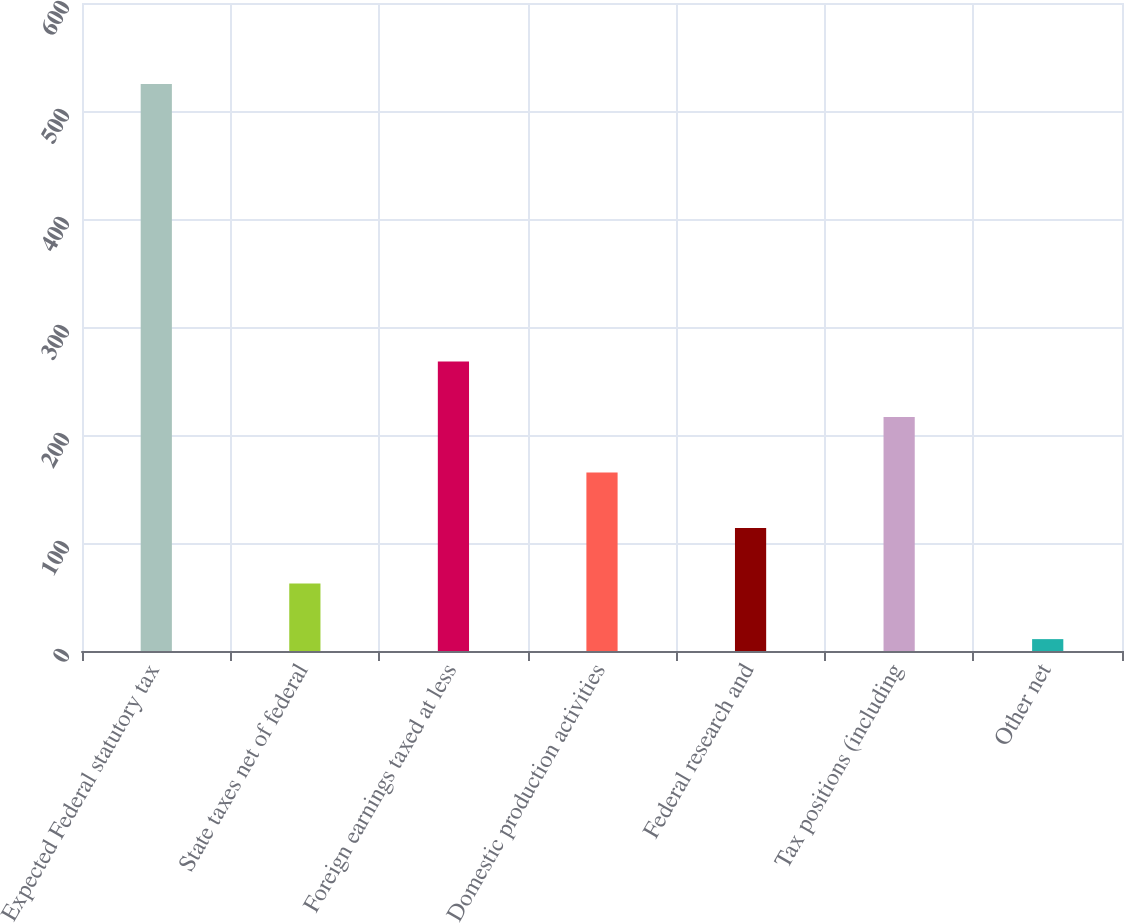<chart> <loc_0><loc_0><loc_500><loc_500><bar_chart><fcel>Expected Federal statutory tax<fcel>State taxes net of federal<fcel>Foreign earnings taxed at less<fcel>Domestic production activities<fcel>Federal research and<fcel>Tax positions (including<fcel>Other net<nl><fcel>525<fcel>62.4<fcel>268<fcel>165.2<fcel>113.8<fcel>216.6<fcel>11<nl></chart> 